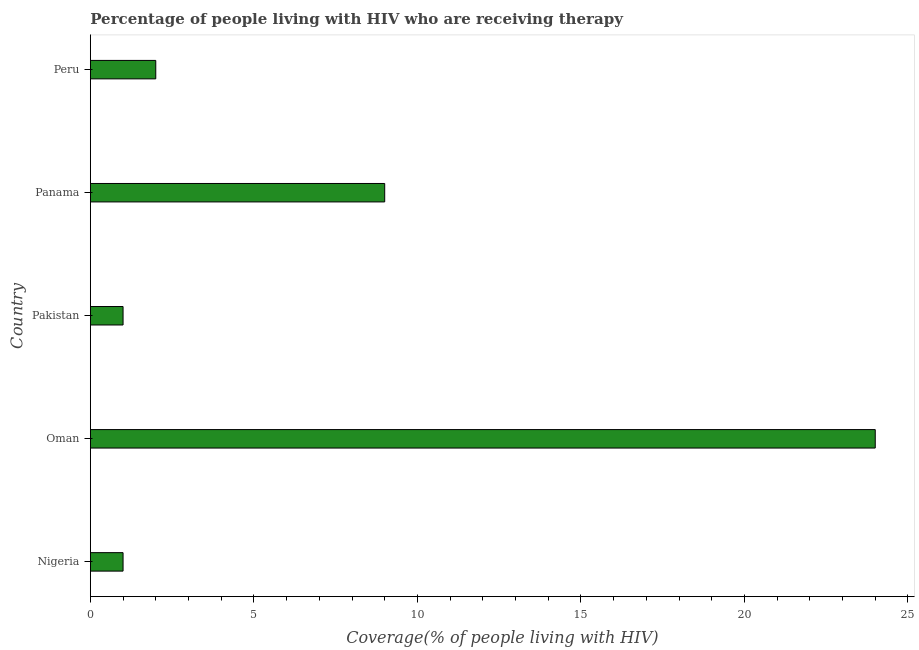Does the graph contain any zero values?
Make the answer very short. No. What is the title of the graph?
Give a very brief answer. Percentage of people living with HIV who are receiving therapy. What is the label or title of the X-axis?
Make the answer very short. Coverage(% of people living with HIV). What is the label or title of the Y-axis?
Your response must be concise. Country. Across all countries, what is the maximum antiretroviral therapy coverage?
Give a very brief answer. 24. In which country was the antiretroviral therapy coverage maximum?
Make the answer very short. Oman. In which country was the antiretroviral therapy coverage minimum?
Your answer should be compact. Nigeria. What is the average antiretroviral therapy coverage per country?
Ensure brevity in your answer.  7.4. What is the median antiretroviral therapy coverage?
Your answer should be very brief. 2. In how many countries, is the antiretroviral therapy coverage greater than 2 %?
Keep it short and to the point. 2. What is the ratio of the antiretroviral therapy coverage in Oman to that in Peru?
Make the answer very short. 12. Is the antiretroviral therapy coverage in Oman less than that in Panama?
Your answer should be compact. No. Is the difference between the antiretroviral therapy coverage in Oman and Pakistan greater than the difference between any two countries?
Provide a short and direct response. Yes. What is the difference between the highest and the second highest antiretroviral therapy coverage?
Offer a very short reply. 15. In how many countries, is the antiretroviral therapy coverage greater than the average antiretroviral therapy coverage taken over all countries?
Offer a terse response. 2. How many bars are there?
Provide a short and direct response. 5. Are all the bars in the graph horizontal?
Your response must be concise. Yes. What is the difference between two consecutive major ticks on the X-axis?
Provide a succinct answer. 5. Are the values on the major ticks of X-axis written in scientific E-notation?
Your answer should be very brief. No. What is the Coverage(% of people living with HIV) of Nigeria?
Your answer should be very brief. 1. What is the Coverage(% of people living with HIV) in Oman?
Your answer should be compact. 24. What is the Coverage(% of people living with HIV) of Pakistan?
Offer a very short reply. 1. What is the Coverage(% of people living with HIV) in Peru?
Make the answer very short. 2. What is the difference between the Coverage(% of people living with HIV) in Nigeria and Pakistan?
Offer a terse response. 0. What is the difference between the Coverage(% of people living with HIV) in Nigeria and Panama?
Your response must be concise. -8. What is the difference between the Coverage(% of people living with HIV) in Nigeria and Peru?
Give a very brief answer. -1. What is the difference between the Coverage(% of people living with HIV) in Oman and Panama?
Give a very brief answer. 15. What is the difference between the Coverage(% of people living with HIV) in Oman and Peru?
Offer a terse response. 22. What is the difference between the Coverage(% of people living with HIV) in Pakistan and Panama?
Provide a short and direct response. -8. What is the ratio of the Coverage(% of people living with HIV) in Nigeria to that in Oman?
Provide a succinct answer. 0.04. What is the ratio of the Coverage(% of people living with HIV) in Nigeria to that in Pakistan?
Offer a very short reply. 1. What is the ratio of the Coverage(% of people living with HIV) in Nigeria to that in Panama?
Your answer should be compact. 0.11. What is the ratio of the Coverage(% of people living with HIV) in Nigeria to that in Peru?
Your answer should be compact. 0.5. What is the ratio of the Coverage(% of people living with HIV) in Oman to that in Pakistan?
Ensure brevity in your answer.  24. What is the ratio of the Coverage(% of people living with HIV) in Oman to that in Panama?
Offer a very short reply. 2.67. What is the ratio of the Coverage(% of people living with HIV) in Oman to that in Peru?
Give a very brief answer. 12. What is the ratio of the Coverage(% of people living with HIV) in Pakistan to that in Panama?
Provide a succinct answer. 0.11. What is the ratio of the Coverage(% of people living with HIV) in Pakistan to that in Peru?
Your answer should be compact. 0.5. What is the ratio of the Coverage(% of people living with HIV) in Panama to that in Peru?
Offer a terse response. 4.5. 